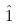Convert formula to latex. <formula><loc_0><loc_0><loc_500><loc_500>\hat { 1 }</formula> 